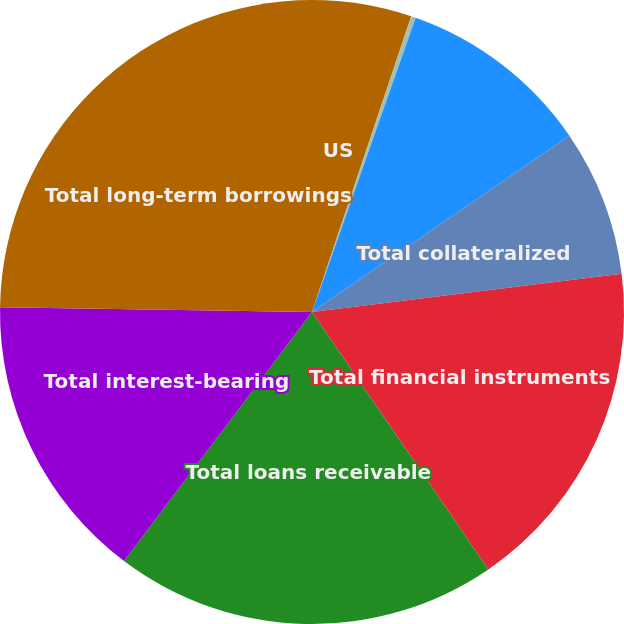Convert chart. <chart><loc_0><loc_0><loc_500><loc_500><pie_chart><fcel>US<fcel>Non-US<fcel>Total deposits with banks<fcel>Total collateralized<fcel>Total financial instruments<fcel>Total loans receivable<fcel>Total interest-bearing<fcel>Total long-term borrowings<nl><fcel>5.15%<fcel>0.24%<fcel>10.05%<fcel>7.6%<fcel>17.4%<fcel>19.85%<fcel>14.95%<fcel>24.76%<nl></chart> 